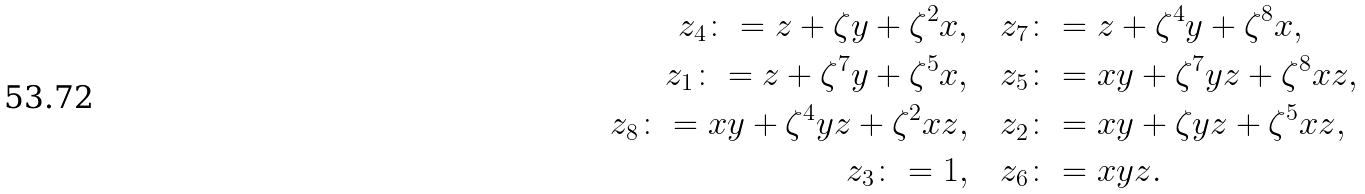Convert formula to latex. <formula><loc_0><loc_0><loc_500><loc_500>z _ { 4 } \colon = z + \zeta y + \zeta ^ { 2 } x , & \quad z _ { 7 } \colon = z + \zeta ^ { 4 } y + \zeta ^ { 8 } x , \\ z _ { 1 } \colon = z + \zeta ^ { 7 } y + \zeta ^ { 5 } x , & \quad z _ { 5 } \colon = x y + \zeta ^ { 7 } y z + \zeta ^ { 8 } x z , \\ z _ { 8 } \colon = x y + \zeta ^ { 4 } y z + \zeta ^ { 2 } x z , & \quad z _ { 2 } \colon = x y + \zeta y z + \zeta ^ { 5 } x z , \\ z _ { 3 } \colon = 1 , & \quad z _ { 6 } \colon = x y z .</formula> 